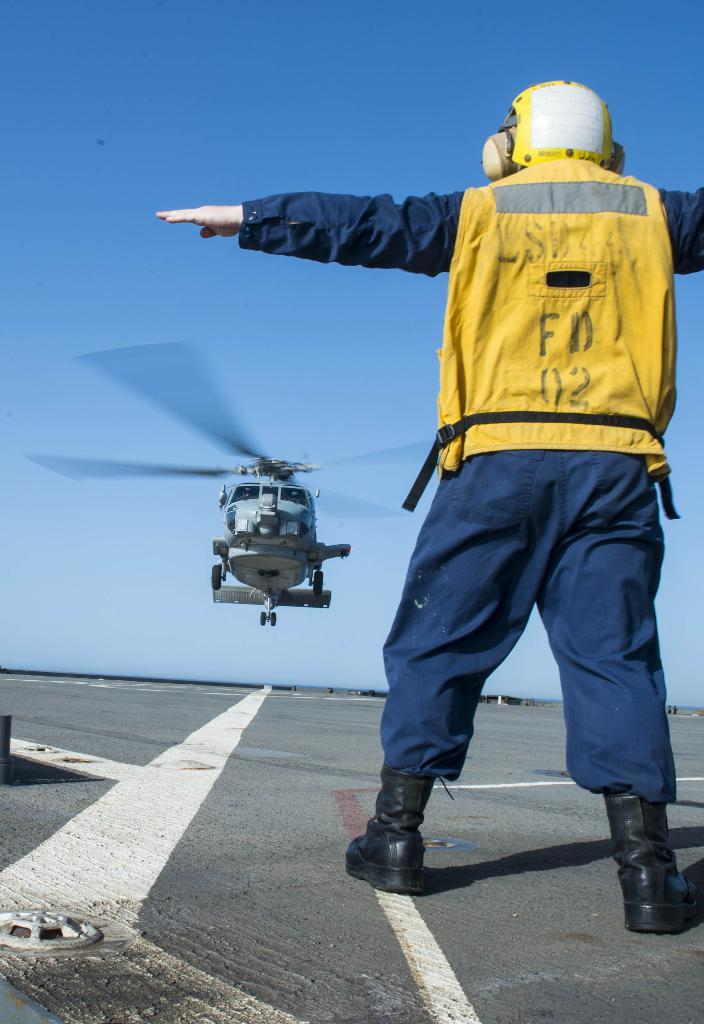<image>
Describe the image concisely. the logo of FD 02 can be seen on the back of the vest that is being worn by a man on a heliport. 